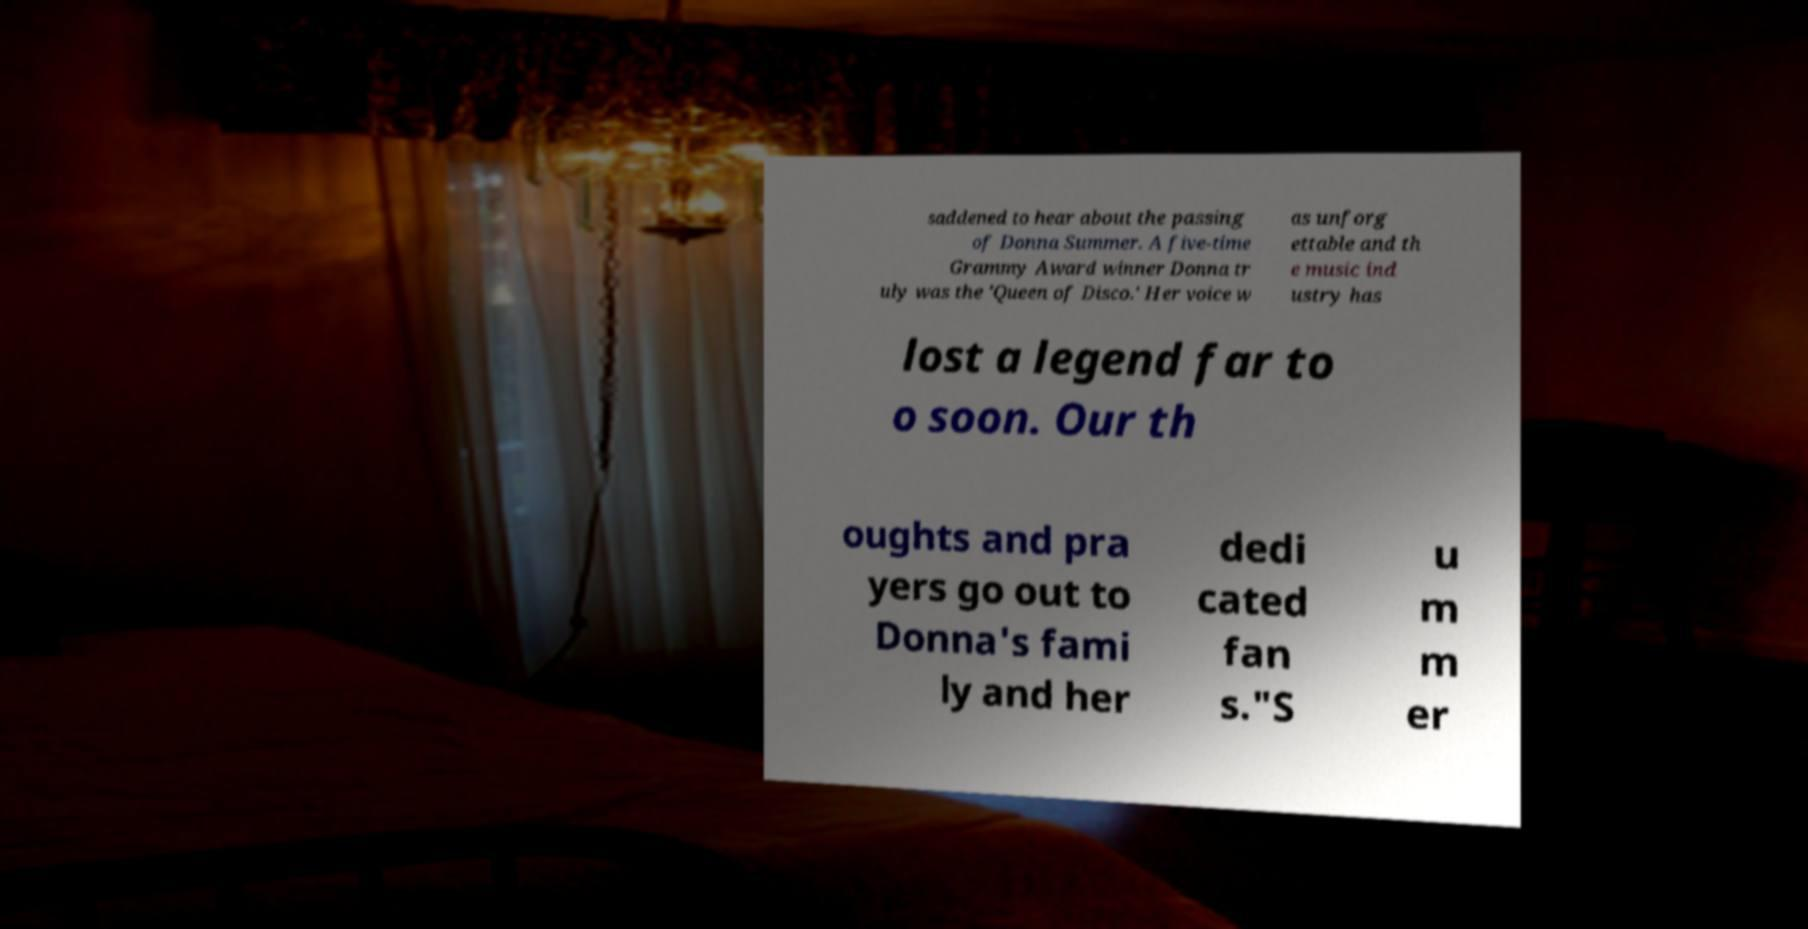There's text embedded in this image that I need extracted. Can you transcribe it verbatim? saddened to hear about the passing of Donna Summer. A five-time Grammy Award winner Donna tr uly was the 'Queen of Disco.' Her voice w as unforg ettable and th e music ind ustry has lost a legend far to o soon. Our th oughts and pra yers go out to Donna's fami ly and her dedi cated fan s."S u m m er 